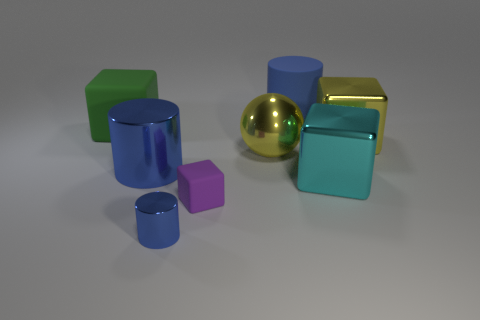There is a thing that is both to the right of the tiny metallic cylinder and in front of the cyan metallic object; what material is it?
Make the answer very short. Rubber. Are the purple cube and the block to the right of the cyan metallic object made of the same material?
Your answer should be compact. No. Is the number of yellow metallic blocks that are to the left of the shiny ball greater than the number of tiny blue shiny things to the left of the large cyan thing?
Offer a very short reply. No. The purple object has what shape?
Offer a very short reply. Cube. Is the material of the big cylinder to the right of the metallic sphere the same as the thing on the right side of the big cyan metal object?
Give a very brief answer. No. The thing that is behind the green matte object has what shape?
Make the answer very short. Cylinder. There is another blue metallic thing that is the same shape as the tiny metal object; what is its size?
Make the answer very short. Large. Do the sphere and the tiny rubber object have the same color?
Your response must be concise. No. Is there anything else that has the same shape as the green thing?
Keep it short and to the point. Yes. There is a big cylinder in front of the green object; is there a large shiny cylinder that is on the left side of it?
Ensure brevity in your answer.  No. 